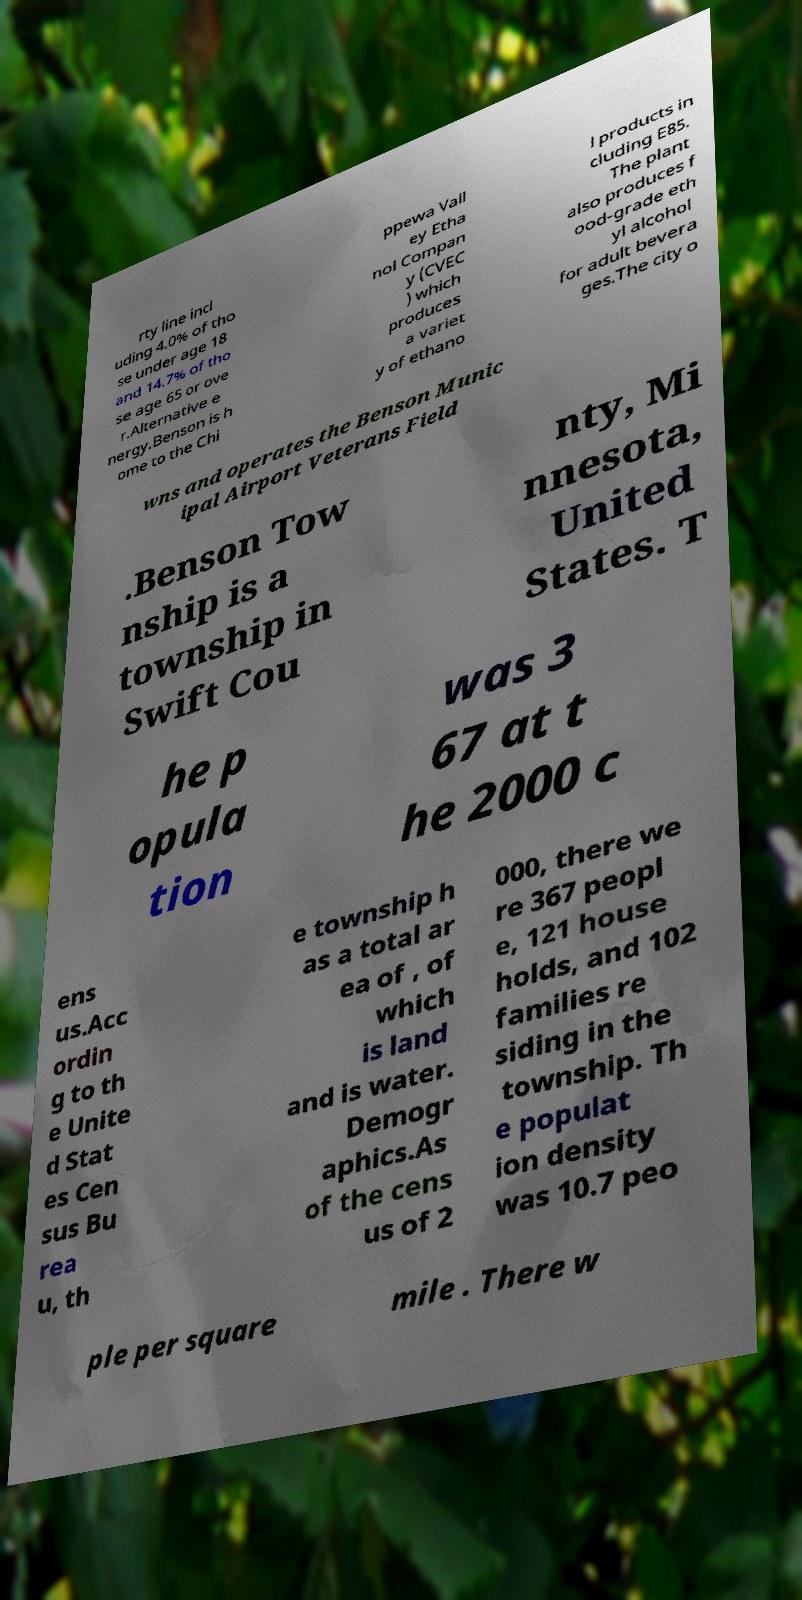I need the written content from this picture converted into text. Can you do that? rty line incl uding 4.0% of tho se under age 18 and 14.7% of tho se age 65 or ove r.Alternative e nergy.Benson is h ome to the Chi ppewa Vall ey Etha nol Compan y (CVEC ) which produces a variet y of ethano l products in cluding E85. The plant also produces f ood-grade eth yl alcohol for adult bevera ges.The city o wns and operates the Benson Munic ipal Airport Veterans Field .Benson Tow nship is a township in Swift Cou nty, Mi nnesota, United States. T he p opula tion was 3 67 at t he 2000 c ens us.Acc ordin g to th e Unite d Stat es Cen sus Bu rea u, th e township h as a total ar ea of , of which is land and is water. Demogr aphics.As of the cens us of 2 000, there we re 367 peopl e, 121 house holds, and 102 families re siding in the township. Th e populat ion density was 10.7 peo ple per square mile . There w 